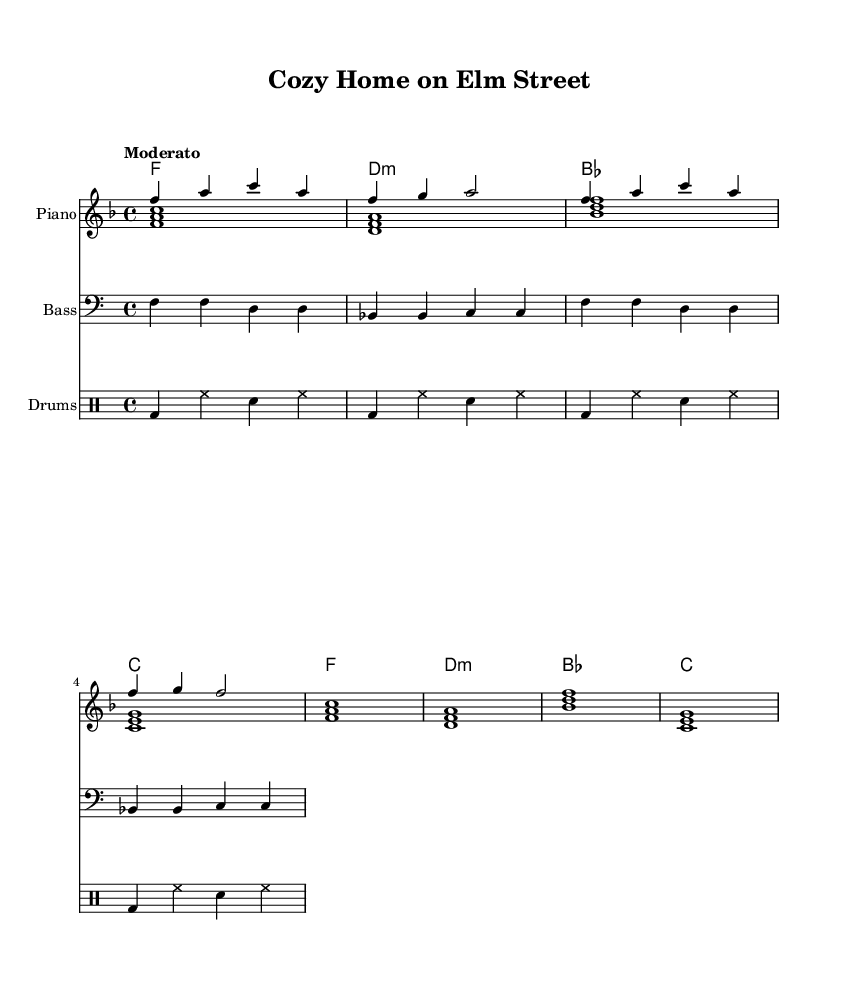What is the key signature of this music? The key signature is indicated by the key signature symbol found at the beginning of the staff. Here, it indicates F major, which has one flat (B flat).
Answer: F major What is the time signature of this music? The time signature, which tells you how many beats are in each measure and what note value gets the beat, is located at the beginning of the score. Here, it shows 4/4, meaning there are four beats per measure, with the quarter note getting one beat.
Answer: 4/4 What is the tempo marking of the piece? The tempo marking, located at the beginning of the piece, provides the speed at which to play. In this case, it is indicated as “Moderato,” which generally translates to a moderate speed.
Answer: Moderato How many measures are in the melody? By counting the number of vertical lines (bar lines) in the melody, we find the number of measures. The melody shown has four measures before ending.
Answer: 4 What is the primary instrument indicated for the melody? The primary instrument for the melody is indicated on the staff where the melody is written. It states "Piano," showing that the melody is meant to be played on the piano.
Answer: Piano Which chord appears first in the harmony? The first chord in the harmony is indicated at the beginning of the chord symbols. It shows an F major chord as the first one.
Answer: F What type of drums are used in the drum part? The drum part includes specific notations that denote the types of drums used. The notation shows a bass drum (bd), hi-hat (hh), and snare (sn), indicating these specific drum types.
Answer: Bass drum, hi-hat, snare 